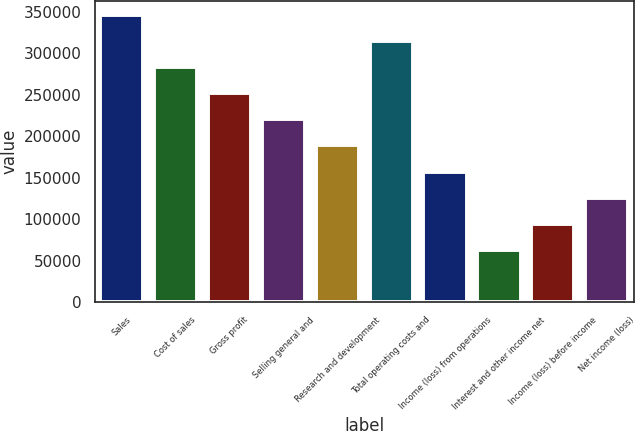Convert chart to OTSL. <chart><loc_0><loc_0><loc_500><loc_500><bar_chart><fcel>Sales<fcel>Cost of sales<fcel>Gross profit<fcel>Selling general and<fcel>Research and development<fcel>Total operating costs and<fcel>Income (loss) from operations<fcel>Interest and other income net<fcel>Income (loss) before income<fcel>Net income (loss)<nl><fcel>346493<fcel>283495<fcel>251995<fcel>220496<fcel>188997<fcel>314994<fcel>157497<fcel>62999.1<fcel>94498.5<fcel>125998<nl></chart> 